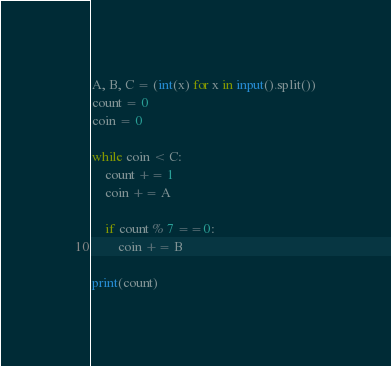Convert code to text. <code><loc_0><loc_0><loc_500><loc_500><_Python_>A, B, C = (int(x) for x in input().split())
count = 0
coin = 0

while coin < C:
    count += 1
    coin += A
    
    if count % 7 ==0:
        coin += B
        
print(count)

</code> 